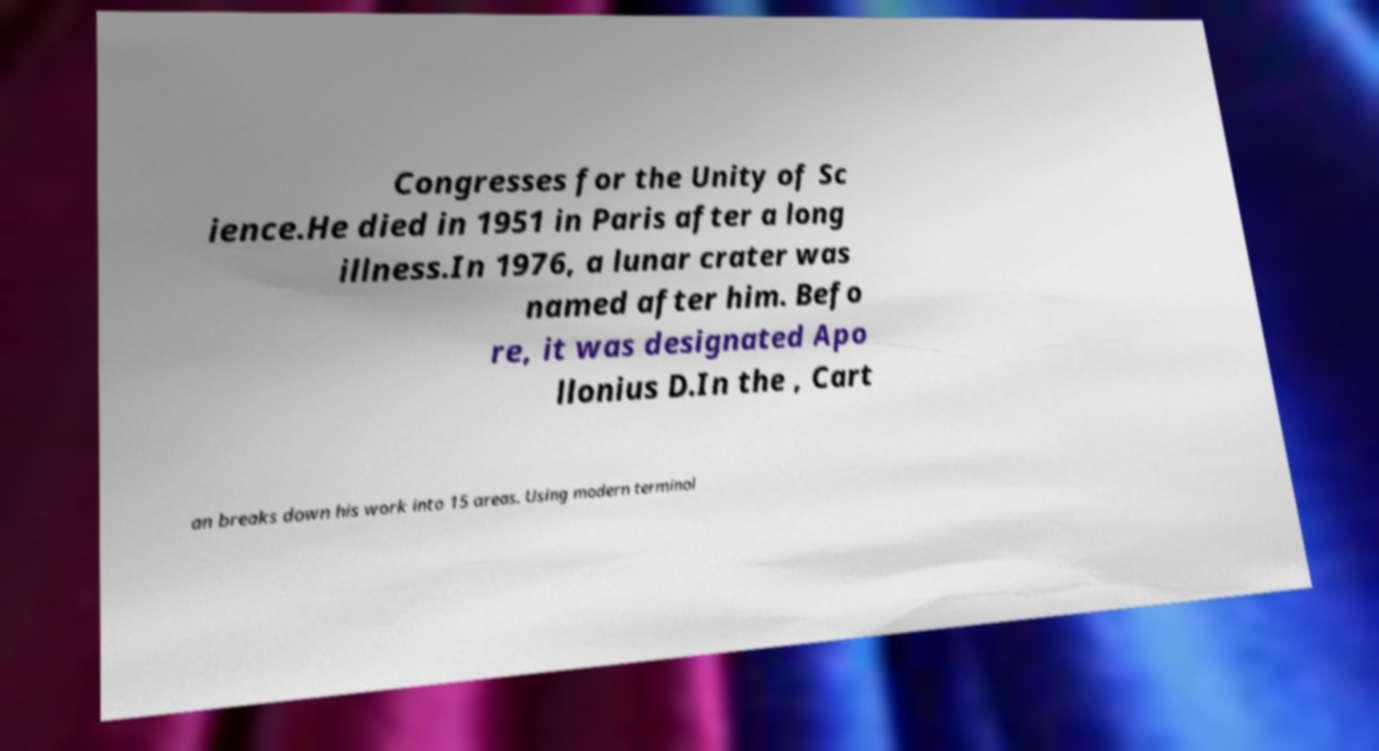There's text embedded in this image that I need extracted. Can you transcribe it verbatim? Congresses for the Unity of Sc ience.He died in 1951 in Paris after a long illness.In 1976, a lunar crater was named after him. Befo re, it was designated Apo llonius D.In the , Cart an breaks down his work into 15 areas. Using modern terminol 